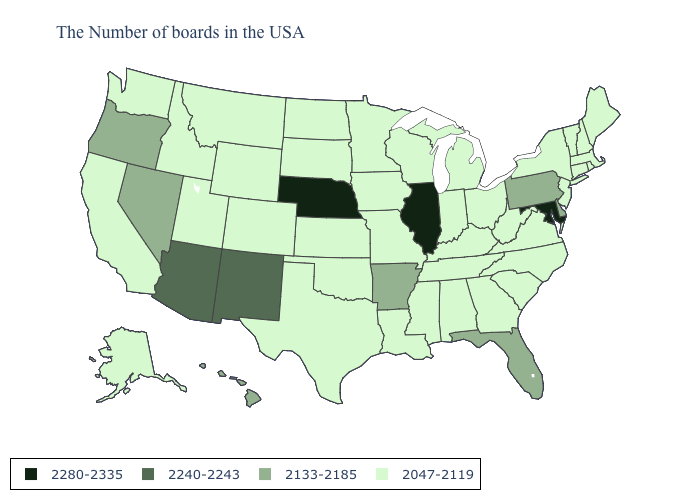Name the states that have a value in the range 2280-2335?
Be succinct. Maryland, Illinois, Nebraska. Name the states that have a value in the range 2047-2119?
Be succinct. Maine, Massachusetts, Rhode Island, New Hampshire, Vermont, Connecticut, New York, New Jersey, Virginia, North Carolina, South Carolina, West Virginia, Ohio, Georgia, Michigan, Kentucky, Indiana, Alabama, Tennessee, Wisconsin, Mississippi, Louisiana, Missouri, Minnesota, Iowa, Kansas, Oklahoma, Texas, South Dakota, North Dakota, Wyoming, Colorado, Utah, Montana, Idaho, California, Washington, Alaska. Among the states that border Virginia , does Tennessee have the lowest value?
Keep it brief. Yes. Does Vermont have the highest value in the Northeast?
Write a very short answer. No. What is the highest value in states that border Maine?
Answer briefly. 2047-2119. What is the value of North Carolina?
Give a very brief answer. 2047-2119. Among the states that border Idaho , which have the highest value?
Answer briefly. Nevada, Oregon. Name the states that have a value in the range 2133-2185?
Quick response, please. Delaware, Pennsylvania, Florida, Arkansas, Nevada, Oregon, Hawaii. Name the states that have a value in the range 2047-2119?
Short answer required. Maine, Massachusetts, Rhode Island, New Hampshire, Vermont, Connecticut, New York, New Jersey, Virginia, North Carolina, South Carolina, West Virginia, Ohio, Georgia, Michigan, Kentucky, Indiana, Alabama, Tennessee, Wisconsin, Mississippi, Louisiana, Missouri, Minnesota, Iowa, Kansas, Oklahoma, Texas, South Dakota, North Dakota, Wyoming, Colorado, Utah, Montana, Idaho, California, Washington, Alaska. Which states have the lowest value in the West?
Short answer required. Wyoming, Colorado, Utah, Montana, Idaho, California, Washington, Alaska. What is the value of Wyoming?
Give a very brief answer. 2047-2119. Does Vermont have the lowest value in the USA?
Give a very brief answer. Yes. Is the legend a continuous bar?
Answer briefly. No. What is the value of North Carolina?
Short answer required. 2047-2119. Name the states that have a value in the range 2047-2119?
Quick response, please. Maine, Massachusetts, Rhode Island, New Hampshire, Vermont, Connecticut, New York, New Jersey, Virginia, North Carolina, South Carolina, West Virginia, Ohio, Georgia, Michigan, Kentucky, Indiana, Alabama, Tennessee, Wisconsin, Mississippi, Louisiana, Missouri, Minnesota, Iowa, Kansas, Oklahoma, Texas, South Dakota, North Dakota, Wyoming, Colorado, Utah, Montana, Idaho, California, Washington, Alaska. 